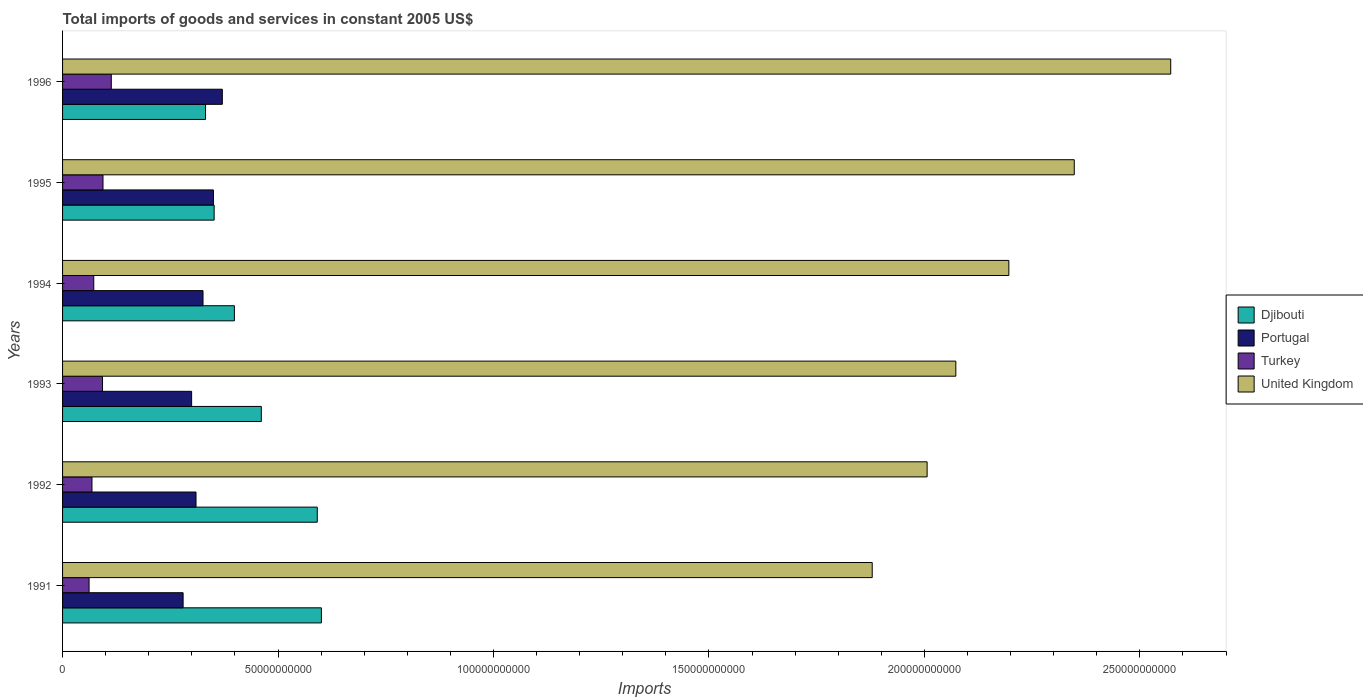How many bars are there on the 3rd tick from the top?
Offer a very short reply. 4. What is the label of the 4th group of bars from the top?
Offer a very short reply. 1993. What is the total imports of goods and services in Turkey in 1996?
Provide a succinct answer. 1.13e+1. Across all years, what is the maximum total imports of goods and services in Djibouti?
Ensure brevity in your answer.  6.01e+1. Across all years, what is the minimum total imports of goods and services in Djibouti?
Make the answer very short. 3.32e+1. What is the total total imports of goods and services in Turkey in the graph?
Give a very brief answer. 5.02e+1. What is the difference between the total imports of goods and services in Djibouti in 1991 and that in 1993?
Your answer should be very brief. 1.39e+1. What is the difference between the total imports of goods and services in United Kingdom in 1994 and the total imports of goods and services in Turkey in 1993?
Provide a succinct answer. 2.10e+11. What is the average total imports of goods and services in Turkey per year?
Make the answer very short. 8.36e+09. In the year 1993, what is the difference between the total imports of goods and services in Turkey and total imports of goods and services in Djibouti?
Offer a very short reply. -3.69e+1. What is the ratio of the total imports of goods and services in Djibouti in 1994 to that in 1996?
Ensure brevity in your answer.  1.2. Is the total imports of goods and services in Turkey in 1992 less than that in 1994?
Offer a very short reply. Yes. Is the difference between the total imports of goods and services in Turkey in 1991 and 1994 greater than the difference between the total imports of goods and services in Djibouti in 1991 and 1994?
Provide a short and direct response. No. What is the difference between the highest and the second highest total imports of goods and services in Portugal?
Give a very brief answer. 2.06e+09. What is the difference between the highest and the lowest total imports of goods and services in Djibouti?
Your answer should be very brief. 2.69e+1. Is the sum of the total imports of goods and services in Turkey in 1993 and 1994 greater than the maximum total imports of goods and services in Djibouti across all years?
Your answer should be very brief. No. Is it the case that in every year, the sum of the total imports of goods and services in Turkey and total imports of goods and services in Portugal is greater than the sum of total imports of goods and services in United Kingdom and total imports of goods and services in Djibouti?
Provide a succinct answer. No. Is it the case that in every year, the sum of the total imports of goods and services in Portugal and total imports of goods and services in United Kingdom is greater than the total imports of goods and services in Djibouti?
Provide a short and direct response. Yes. How many bars are there?
Your answer should be compact. 24. Are all the bars in the graph horizontal?
Provide a short and direct response. Yes. How many years are there in the graph?
Offer a very short reply. 6. Does the graph contain any zero values?
Your response must be concise. No. How are the legend labels stacked?
Your response must be concise. Vertical. What is the title of the graph?
Provide a short and direct response. Total imports of goods and services in constant 2005 US$. Does "Jamaica" appear as one of the legend labels in the graph?
Offer a terse response. No. What is the label or title of the X-axis?
Provide a succinct answer. Imports. What is the label or title of the Y-axis?
Offer a very short reply. Years. What is the Imports in Djibouti in 1991?
Keep it short and to the point. 6.01e+1. What is the Imports of Portugal in 1991?
Give a very brief answer. 2.80e+1. What is the Imports of Turkey in 1991?
Offer a very short reply. 6.15e+09. What is the Imports in United Kingdom in 1991?
Give a very brief answer. 1.88e+11. What is the Imports in Djibouti in 1992?
Offer a very short reply. 5.91e+1. What is the Imports of Portugal in 1992?
Provide a succinct answer. 3.10e+1. What is the Imports in Turkey in 1992?
Keep it short and to the point. 6.82e+09. What is the Imports of United Kingdom in 1992?
Your response must be concise. 2.01e+11. What is the Imports of Djibouti in 1993?
Your answer should be compact. 4.61e+1. What is the Imports of Portugal in 1993?
Offer a very short reply. 2.99e+1. What is the Imports in Turkey in 1993?
Offer a very short reply. 9.27e+09. What is the Imports of United Kingdom in 1993?
Make the answer very short. 2.07e+11. What is the Imports of Djibouti in 1994?
Offer a terse response. 3.99e+1. What is the Imports in Portugal in 1994?
Make the answer very short. 3.26e+1. What is the Imports of Turkey in 1994?
Ensure brevity in your answer.  7.24e+09. What is the Imports of United Kingdom in 1994?
Provide a succinct answer. 2.20e+11. What is the Imports in Djibouti in 1995?
Your response must be concise. 3.52e+1. What is the Imports in Portugal in 1995?
Make the answer very short. 3.50e+1. What is the Imports in Turkey in 1995?
Your answer should be compact. 9.38e+09. What is the Imports in United Kingdom in 1995?
Your answer should be compact. 2.35e+11. What is the Imports in Djibouti in 1996?
Your answer should be compact. 3.32e+1. What is the Imports in Portugal in 1996?
Provide a short and direct response. 3.71e+1. What is the Imports in Turkey in 1996?
Keep it short and to the point. 1.13e+1. What is the Imports of United Kingdom in 1996?
Offer a terse response. 2.57e+11. Across all years, what is the maximum Imports of Djibouti?
Make the answer very short. 6.01e+1. Across all years, what is the maximum Imports in Portugal?
Your response must be concise. 3.71e+1. Across all years, what is the maximum Imports in Turkey?
Give a very brief answer. 1.13e+1. Across all years, what is the maximum Imports of United Kingdom?
Offer a terse response. 2.57e+11. Across all years, what is the minimum Imports in Djibouti?
Make the answer very short. 3.32e+1. Across all years, what is the minimum Imports in Portugal?
Keep it short and to the point. 2.80e+1. Across all years, what is the minimum Imports of Turkey?
Offer a very short reply. 6.15e+09. Across all years, what is the minimum Imports of United Kingdom?
Your response must be concise. 1.88e+11. What is the total Imports in Djibouti in the graph?
Make the answer very short. 2.74e+11. What is the total Imports of Portugal in the graph?
Offer a very short reply. 1.94e+11. What is the total Imports of Turkey in the graph?
Ensure brevity in your answer.  5.02e+1. What is the total Imports of United Kingdom in the graph?
Ensure brevity in your answer.  1.31e+12. What is the difference between the Imports in Djibouti in 1991 and that in 1992?
Your answer should be compact. 9.62e+08. What is the difference between the Imports in Portugal in 1991 and that in 1992?
Provide a succinct answer. -2.99e+09. What is the difference between the Imports in Turkey in 1991 and that in 1992?
Keep it short and to the point. -6.72e+08. What is the difference between the Imports in United Kingdom in 1991 and that in 1992?
Provide a short and direct response. -1.27e+1. What is the difference between the Imports of Djibouti in 1991 and that in 1993?
Keep it short and to the point. 1.39e+1. What is the difference between the Imports in Portugal in 1991 and that in 1993?
Offer a very short reply. -1.97e+09. What is the difference between the Imports of Turkey in 1991 and that in 1993?
Your answer should be very brief. -3.11e+09. What is the difference between the Imports in United Kingdom in 1991 and that in 1993?
Your response must be concise. -1.94e+1. What is the difference between the Imports in Djibouti in 1991 and that in 1994?
Give a very brief answer. 2.02e+1. What is the difference between the Imports in Portugal in 1991 and that in 1994?
Provide a short and direct response. -4.62e+09. What is the difference between the Imports in Turkey in 1991 and that in 1994?
Offer a very short reply. -1.09e+09. What is the difference between the Imports in United Kingdom in 1991 and that in 1994?
Provide a short and direct response. -3.17e+1. What is the difference between the Imports of Djibouti in 1991 and that in 1995?
Offer a terse response. 2.49e+1. What is the difference between the Imports in Portugal in 1991 and that in 1995?
Provide a short and direct response. -7.04e+09. What is the difference between the Imports of Turkey in 1991 and that in 1995?
Provide a short and direct response. -3.23e+09. What is the difference between the Imports of United Kingdom in 1991 and that in 1995?
Give a very brief answer. -4.69e+1. What is the difference between the Imports of Djibouti in 1991 and that in 1996?
Make the answer very short. 2.69e+1. What is the difference between the Imports of Portugal in 1991 and that in 1996?
Provide a succinct answer. -9.10e+09. What is the difference between the Imports in Turkey in 1991 and that in 1996?
Offer a very short reply. -5.15e+09. What is the difference between the Imports in United Kingdom in 1991 and that in 1996?
Your answer should be compact. -6.93e+1. What is the difference between the Imports in Djibouti in 1992 and that in 1993?
Ensure brevity in your answer.  1.30e+1. What is the difference between the Imports of Portugal in 1992 and that in 1993?
Offer a very short reply. 1.02e+09. What is the difference between the Imports of Turkey in 1992 and that in 1993?
Your answer should be compact. -2.44e+09. What is the difference between the Imports of United Kingdom in 1992 and that in 1993?
Keep it short and to the point. -6.66e+09. What is the difference between the Imports in Djibouti in 1992 and that in 1994?
Offer a very short reply. 1.92e+1. What is the difference between the Imports in Portugal in 1992 and that in 1994?
Give a very brief answer. -1.62e+09. What is the difference between the Imports in Turkey in 1992 and that in 1994?
Make the answer very short. -4.15e+08. What is the difference between the Imports of United Kingdom in 1992 and that in 1994?
Keep it short and to the point. -1.90e+1. What is the difference between the Imports of Djibouti in 1992 and that in 1995?
Make the answer very short. 2.39e+1. What is the difference between the Imports in Portugal in 1992 and that in 1995?
Provide a short and direct response. -4.04e+09. What is the difference between the Imports of Turkey in 1992 and that in 1995?
Offer a very short reply. -2.56e+09. What is the difference between the Imports of United Kingdom in 1992 and that in 1995?
Give a very brief answer. -3.41e+1. What is the difference between the Imports of Djibouti in 1992 and that in 1996?
Your answer should be compact. 2.59e+1. What is the difference between the Imports of Portugal in 1992 and that in 1996?
Offer a very short reply. -6.10e+09. What is the difference between the Imports in Turkey in 1992 and that in 1996?
Your answer should be compact. -4.48e+09. What is the difference between the Imports in United Kingdom in 1992 and that in 1996?
Keep it short and to the point. -5.65e+1. What is the difference between the Imports of Djibouti in 1993 and that in 1994?
Your answer should be very brief. 6.25e+09. What is the difference between the Imports of Portugal in 1993 and that in 1994?
Give a very brief answer. -2.64e+09. What is the difference between the Imports in Turkey in 1993 and that in 1994?
Your answer should be very brief. 2.03e+09. What is the difference between the Imports in United Kingdom in 1993 and that in 1994?
Provide a short and direct response. -1.23e+1. What is the difference between the Imports in Djibouti in 1993 and that in 1995?
Your response must be concise. 1.09e+1. What is the difference between the Imports in Portugal in 1993 and that in 1995?
Provide a succinct answer. -5.06e+09. What is the difference between the Imports in Turkey in 1993 and that in 1995?
Make the answer very short. -1.15e+08. What is the difference between the Imports in United Kingdom in 1993 and that in 1995?
Your answer should be very brief. -2.75e+1. What is the difference between the Imports of Djibouti in 1993 and that in 1996?
Make the answer very short. 1.29e+1. What is the difference between the Imports of Portugal in 1993 and that in 1996?
Your response must be concise. -7.13e+09. What is the difference between the Imports of Turkey in 1993 and that in 1996?
Make the answer very short. -2.04e+09. What is the difference between the Imports of United Kingdom in 1993 and that in 1996?
Make the answer very short. -4.99e+1. What is the difference between the Imports of Djibouti in 1994 and that in 1995?
Give a very brief answer. 4.70e+09. What is the difference between the Imports in Portugal in 1994 and that in 1995?
Offer a very short reply. -2.42e+09. What is the difference between the Imports of Turkey in 1994 and that in 1995?
Your answer should be very brief. -2.14e+09. What is the difference between the Imports of United Kingdom in 1994 and that in 1995?
Provide a short and direct response. -1.52e+1. What is the difference between the Imports of Djibouti in 1994 and that in 1996?
Provide a succinct answer. 6.69e+09. What is the difference between the Imports in Portugal in 1994 and that in 1996?
Your response must be concise. -4.48e+09. What is the difference between the Imports in Turkey in 1994 and that in 1996?
Provide a succinct answer. -4.07e+09. What is the difference between the Imports in United Kingdom in 1994 and that in 1996?
Your answer should be compact. -3.76e+1. What is the difference between the Imports of Djibouti in 1995 and that in 1996?
Offer a terse response. 2.00e+09. What is the difference between the Imports of Portugal in 1995 and that in 1996?
Ensure brevity in your answer.  -2.06e+09. What is the difference between the Imports of Turkey in 1995 and that in 1996?
Make the answer very short. -1.93e+09. What is the difference between the Imports of United Kingdom in 1995 and that in 1996?
Your answer should be very brief. -2.24e+1. What is the difference between the Imports of Djibouti in 1991 and the Imports of Portugal in 1992?
Offer a very short reply. 2.91e+1. What is the difference between the Imports of Djibouti in 1991 and the Imports of Turkey in 1992?
Keep it short and to the point. 5.32e+1. What is the difference between the Imports of Djibouti in 1991 and the Imports of United Kingdom in 1992?
Offer a terse response. -1.41e+11. What is the difference between the Imports of Portugal in 1991 and the Imports of Turkey in 1992?
Ensure brevity in your answer.  2.11e+1. What is the difference between the Imports of Portugal in 1991 and the Imports of United Kingdom in 1992?
Your answer should be very brief. -1.73e+11. What is the difference between the Imports of Turkey in 1991 and the Imports of United Kingdom in 1992?
Your answer should be very brief. -1.94e+11. What is the difference between the Imports of Djibouti in 1991 and the Imports of Portugal in 1993?
Ensure brevity in your answer.  3.01e+1. What is the difference between the Imports in Djibouti in 1991 and the Imports in Turkey in 1993?
Provide a short and direct response. 5.08e+1. What is the difference between the Imports in Djibouti in 1991 and the Imports in United Kingdom in 1993?
Offer a very short reply. -1.47e+11. What is the difference between the Imports of Portugal in 1991 and the Imports of Turkey in 1993?
Your answer should be very brief. 1.87e+1. What is the difference between the Imports in Portugal in 1991 and the Imports in United Kingdom in 1993?
Your response must be concise. -1.79e+11. What is the difference between the Imports in Turkey in 1991 and the Imports in United Kingdom in 1993?
Give a very brief answer. -2.01e+11. What is the difference between the Imports of Djibouti in 1991 and the Imports of Portugal in 1994?
Your answer should be very brief. 2.75e+1. What is the difference between the Imports of Djibouti in 1991 and the Imports of Turkey in 1994?
Your answer should be compact. 5.28e+1. What is the difference between the Imports of Djibouti in 1991 and the Imports of United Kingdom in 1994?
Provide a succinct answer. -1.60e+11. What is the difference between the Imports of Portugal in 1991 and the Imports of Turkey in 1994?
Offer a very short reply. 2.07e+1. What is the difference between the Imports of Portugal in 1991 and the Imports of United Kingdom in 1994?
Make the answer very short. -1.92e+11. What is the difference between the Imports of Turkey in 1991 and the Imports of United Kingdom in 1994?
Your answer should be very brief. -2.13e+11. What is the difference between the Imports in Djibouti in 1991 and the Imports in Portugal in 1995?
Offer a very short reply. 2.51e+1. What is the difference between the Imports of Djibouti in 1991 and the Imports of Turkey in 1995?
Make the answer very short. 5.07e+1. What is the difference between the Imports in Djibouti in 1991 and the Imports in United Kingdom in 1995?
Offer a very short reply. -1.75e+11. What is the difference between the Imports in Portugal in 1991 and the Imports in Turkey in 1995?
Provide a succinct answer. 1.86e+1. What is the difference between the Imports in Portugal in 1991 and the Imports in United Kingdom in 1995?
Ensure brevity in your answer.  -2.07e+11. What is the difference between the Imports of Turkey in 1991 and the Imports of United Kingdom in 1995?
Keep it short and to the point. -2.29e+11. What is the difference between the Imports in Djibouti in 1991 and the Imports in Portugal in 1996?
Provide a succinct answer. 2.30e+1. What is the difference between the Imports of Djibouti in 1991 and the Imports of Turkey in 1996?
Offer a very short reply. 4.88e+1. What is the difference between the Imports in Djibouti in 1991 and the Imports in United Kingdom in 1996?
Your answer should be very brief. -1.97e+11. What is the difference between the Imports in Portugal in 1991 and the Imports in Turkey in 1996?
Provide a succinct answer. 1.67e+1. What is the difference between the Imports of Portugal in 1991 and the Imports of United Kingdom in 1996?
Offer a terse response. -2.29e+11. What is the difference between the Imports of Turkey in 1991 and the Imports of United Kingdom in 1996?
Your response must be concise. -2.51e+11. What is the difference between the Imports of Djibouti in 1992 and the Imports of Portugal in 1993?
Provide a succinct answer. 2.92e+1. What is the difference between the Imports of Djibouti in 1992 and the Imports of Turkey in 1993?
Offer a very short reply. 4.98e+1. What is the difference between the Imports in Djibouti in 1992 and the Imports in United Kingdom in 1993?
Your answer should be very brief. -1.48e+11. What is the difference between the Imports of Portugal in 1992 and the Imports of Turkey in 1993?
Your response must be concise. 2.17e+1. What is the difference between the Imports of Portugal in 1992 and the Imports of United Kingdom in 1993?
Provide a succinct answer. -1.76e+11. What is the difference between the Imports of Turkey in 1992 and the Imports of United Kingdom in 1993?
Provide a short and direct response. -2.00e+11. What is the difference between the Imports in Djibouti in 1992 and the Imports in Portugal in 1994?
Your response must be concise. 2.65e+1. What is the difference between the Imports of Djibouti in 1992 and the Imports of Turkey in 1994?
Offer a terse response. 5.19e+1. What is the difference between the Imports of Djibouti in 1992 and the Imports of United Kingdom in 1994?
Make the answer very short. -1.60e+11. What is the difference between the Imports in Portugal in 1992 and the Imports in Turkey in 1994?
Provide a short and direct response. 2.37e+1. What is the difference between the Imports of Portugal in 1992 and the Imports of United Kingdom in 1994?
Your answer should be compact. -1.89e+11. What is the difference between the Imports in Turkey in 1992 and the Imports in United Kingdom in 1994?
Offer a terse response. -2.13e+11. What is the difference between the Imports of Djibouti in 1992 and the Imports of Portugal in 1995?
Your response must be concise. 2.41e+1. What is the difference between the Imports of Djibouti in 1992 and the Imports of Turkey in 1995?
Your answer should be compact. 4.97e+1. What is the difference between the Imports in Djibouti in 1992 and the Imports in United Kingdom in 1995?
Provide a succinct answer. -1.76e+11. What is the difference between the Imports in Portugal in 1992 and the Imports in Turkey in 1995?
Provide a short and direct response. 2.16e+1. What is the difference between the Imports in Portugal in 1992 and the Imports in United Kingdom in 1995?
Your answer should be compact. -2.04e+11. What is the difference between the Imports of Turkey in 1992 and the Imports of United Kingdom in 1995?
Offer a terse response. -2.28e+11. What is the difference between the Imports in Djibouti in 1992 and the Imports in Portugal in 1996?
Give a very brief answer. 2.20e+1. What is the difference between the Imports of Djibouti in 1992 and the Imports of Turkey in 1996?
Provide a succinct answer. 4.78e+1. What is the difference between the Imports in Djibouti in 1992 and the Imports in United Kingdom in 1996?
Ensure brevity in your answer.  -1.98e+11. What is the difference between the Imports of Portugal in 1992 and the Imports of Turkey in 1996?
Your answer should be very brief. 1.97e+1. What is the difference between the Imports of Portugal in 1992 and the Imports of United Kingdom in 1996?
Provide a succinct answer. -2.26e+11. What is the difference between the Imports in Turkey in 1992 and the Imports in United Kingdom in 1996?
Offer a terse response. -2.50e+11. What is the difference between the Imports in Djibouti in 1993 and the Imports in Portugal in 1994?
Your answer should be very brief. 1.35e+1. What is the difference between the Imports in Djibouti in 1993 and the Imports in Turkey in 1994?
Make the answer very short. 3.89e+1. What is the difference between the Imports of Djibouti in 1993 and the Imports of United Kingdom in 1994?
Your answer should be compact. -1.73e+11. What is the difference between the Imports in Portugal in 1993 and the Imports in Turkey in 1994?
Make the answer very short. 2.27e+1. What is the difference between the Imports of Portugal in 1993 and the Imports of United Kingdom in 1994?
Ensure brevity in your answer.  -1.90e+11. What is the difference between the Imports in Turkey in 1993 and the Imports in United Kingdom in 1994?
Make the answer very short. -2.10e+11. What is the difference between the Imports of Djibouti in 1993 and the Imports of Portugal in 1995?
Ensure brevity in your answer.  1.11e+1. What is the difference between the Imports of Djibouti in 1993 and the Imports of Turkey in 1995?
Provide a succinct answer. 3.67e+1. What is the difference between the Imports of Djibouti in 1993 and the Imports of United Kingdom in 1995?
Provide a succinct answer. -1.89e+11. What is the difference between the Imports of Portugal in 1993 and the Imports of Turkey in 1995?
Ensure brevity in your answer.  2.06e+1. What is the difference between the Imports in Portugal in 1993 and the Imports in United Kingdom in 1995?
Give a very brief answer. -2.05e+11. What is the difference between the Imports of Turkey in 1993 and the Imports of United Kingdom in 1995?
Keep it short and to the point. -2.26e+11. What is the difference between the Imports of Djibouti in 1993 and the Imports of Portugal in 1996?
Keep it short and to the point. 9.05e+09. What is the difference between the Imports of Djibouti in 1993 and the Imports of Turkey in 1996?
Provide a succinct answer. 3.48e+1. What is the difference between the Imports in Djibouti in 1993 and the Imports in United Kingdom in 1996?
Your response must be concise. -2.11e+11. What is the difference between the Imports of Portugal in 1993 and the Imports of Turkey in 1996?
Keep it short and to the point. 1.86e+1. What is the difference between the Imports in Portugal in 1993 and the Imports in United Kingdom in 1996?
Make the answer very short. -2.27e+11. What is the difference between the Imports of Turkey in 1993 and the Imports of United Kingdom in 1996?
Offer a very short reply. -2.48e+11. What is the difference between the Imports of Djibouti in 1994 and the Imports of Portugal in 1995?
Your response must be concise. 4.86e+09. What is the difference between the Imports in Djibouti in 1994 and the Imports in Turkey in 1995?
Offer a terse response. 3.05e+1. What is the difference between the Imports in Djibouti in 1994 and the Imports in United Kingdom in 1995?
Your answer should be very brief. -1.95e+11. What is the difference between the Imports in Portugal in 1994 and the Imports in Turkey in 1995?
Your answer should be compact. 2.32e+1. What is the difference between the Imports in Portugal in 1994 and the Imports in United Kingdom in 1995?
Your answer should be very brief. -2.02e+11. What is the difference between the Imports of Turkey in 1994 and the Imports of United Kingdom in 1995?
Offer a very short reply. -2.28e+11. What is the difference between the Imports in Djibouti in 1994 and the Imports in Portugal in 1996?
Your answer should be very brief. 2.80e+09. What is the difference between the Imports of Djibouti in 1994 and the Imports of Turkey in 1996?
Offer a very short reply. 2.86e+1. What is the difference between the Imports in Djibouti in 1994 and the Imports in United Kingdom in 1996?
Give a very brief answer. -2.17e+11. What is the difference between the Imports in Portugal in 1994 and the Imports in Turkey in 1996?
Your answer should be compact. 2.13e+1. What is the difference between the Imports of Portugal in 1994 and the Imports of United Kingdom in 1996?
Keep it short and to the point. -2.25e+11. What is the difference between the Imports of Turkey in 1994 and the Imports of United Kingdom in 1996?
Provide a succinct answer. -2.50e+11. What is the difference between the Imports in Djibouti in 1995 and the Imports in Portugal in 1996?
Offer a very short reply. -1.90e+09. What is the difference between the Imports of Djibouti in 1995 and the Imports of Turkey in 1996?
Keep it short and to the point. 2.39e+1. What is the difference between the Imports of Djibouti in 1995 and the Imports of United Kingdom in 1996?
Offer a very short reply. -2.22e+11. What is the difference between the Imports in Portugal in 1995 and the Imports in Turkey in 1996?
Ensure brevity in your answer.  2.37e+1. What is the difference between the Imports in Portugal in 1995 and the Imports in United Kingdom in 1996?
Offer a very short reply. -2.22e+11. What is the difference between the Imports of Turkey in 1995 and the Imports of United Kingdom in 1996?
Offer a terse response. -2.48e+11. What is the average Imports of Djibouti per year?
Provide a short and direct response. 4.56e+1. What is the average Imports of Portugal per year?
Provide a succinct answer. 3.23e+1. What is the average Imports in Turkey per year?
Your response must be concise. 8.36e+09. What is the average Imports of United Kingdom per year?
Keep it short and to the point. 2.18e+11. In the year 1991, what is the difference between the Imports in Djibouti and Imports in Portugal?
Your answer should be compact. 3.21e+1. In the year 1991, what is the difference between the Imports of Djibouti and Imports of Turkey?
Your answer should be compact. 5.39e+1. In the year 1991, what is the difference between the Imports of Djibouti and Imports of United Kingdom?
Your answer should be very brief. -1.28e+11. In the year 1991, what is the difference between the Imports of Portugal and Imports of Turkey?
Provide a short and direct response. 2.18e+1. In the year 1991, what is the difference between the Imports of Portugal and Imports of United Kingdom?
Give a very brief answer. -1.60e+11. In the year 1991, what is the difference between the Imports of Turkey and Imports of United Kingdom?
Make the answer very short. -1.82e+11. In the year 1992, what is the difference between the Imports in Djibouti and Imports in Portugal?
Your answer should be very brief. 2.81e+1. In the year 1992, what is the difference between the Imports in Djibouti and Imports in Turkey?
Your answer should be compact. 5.23e+1. In the year 1992, what is the difference between the Imports in Djibouti and Imports in United Kingdom?
Your response must be concise. -1.42e+11. In the year 1992, what is the difference between the Imports of Portugal and Imports of Turkey?
Ensure brevity in your answer.  2.41e+1. In the year 1992, what is the difference between the Imports in Portugal and Imports in United Kingdom?
Provide a short and direct response. -1.70e+11. In the year 1992, what is the difference between the Imports of Turkey and Imports of United Kingdom?
Make the answer very short. -1.94e+11. In the year 1993, what is the difference between the Imports of Djibouti and Imports of Portugal?
Offer a very short reply. 1.62e+1. In the year 1993, what is the difference between the Imports in Djibouti and Imports in Turkey?
Make the answer very short. 3.69e+1. In the year 1993, what is the difference between the Imports of Djibouti and Imports of United Kingdom?
Your answer should be very brief. -1.61e+11. In the year 1993, what is the difference between the Imports of Portugal and Imports of Turkey?
Provide a short and direct response. 2.07e+1. In the year 1993, what is the difference between the Imports in Portugal and Imports in United Kingdom?
Give a very brief answer. -1.77e+11. In the year 1993, what is the difference between the Imports in Turkey and Imports in United Kingdom?
Provide a succinct answer. -1.98e+11. In the year 1994, what is the difference between the Imports in Djibouti and Imports in Portugal?
Give a very brief answer. 7.28e+09. In the year 1994, what is the difference between the Imports of Djibouti and Imports of Turkey?
Offer a very short reply. 3.26e+1. In the year 1994, what is the difference between the Imports in Djibouti and Imports in United Kingdom?
Keep it short and to the point. -1.80e+11. In the year 1994, what is the difference between the Imports of Portugal and Imports of Turkey?
Offer a terse response. 2.54e+1. In the year 1994, what is the difference between the Imports in Portugal and Imports in United Kingdom?
Keep it short and to the point. -1.87e+11. In the year 1994, what is the difference between the Imports of Turkey and Imports of United Kingdom?
Your response must be concise. -2.12e+11. In the year 1995, what is the difference between the Imports of Djibouti and Imports of Portugal?
Offer a terse response. 1.65e+08. In the year 1995, what is the difference between the Imports of Djibouti and Imports of Turkey?
Your answer should be compact. 2.58e+1. In the year 1995, what is the difference between the Imports of Djibouti and Imports of United Kingdom?
Provide a short and direct response. -2.00e+11. In the year 1995, what is the difference between the Imports in Portugal and Imports in Turkey?
Offer a very short reply. 2.56e+1. In the year 1995, what is the difference between the Imports in Portugal and Imports in United Kingdom?
Ensure brevity in your answer.  -2.00e+11. In the year 1995, what is the difference between the Imports of Turkey and Imports of United Kingdom?
Offer a terse response. -2.25e+11. In the year 1996, what is the difference between the Imports of Djibouti and Imports of Portugal?
Ensure brevity in your answer.  -3.90e+09. In the year 1996, what is the difference between the Imports in Djibouti and Imports in Turkey?
Your response must be concise. 2.19e+1. In the year 1996, what is the difference between the Imports of Djibouti and Imports of United Kingdom?
Make the answer very short. -2.24e+11. In the year 1996, what is the difference between the Imports of Portugal and Imports of Turkey?
Keep it short and to the point. 2.58e+1. In the year 1996, what is the difference between the Imports in Portugal and Imports in United Kingdom?
Offer a terse response. -2.20e+11. In the year 1996, what is the difference between the Imports of Turkey and Imports of United Kingdom?
Your response must be concise. -2.46e+11. What is the ratio of the Imports of Djibouti in 1991 to that in 1992?
Keep it short and to the point. 1.02. What is the ratio of the Imports in Portugal in 1991 to that in 1992?
Offer a very short reply. 0.9. What is the ratio of the Imports of Turkey in 1991 to that in 1992?
Provide a succinct answer. 0.9. What is the ratio of the Imports of United Kingdom in 1991 to that in 1992?
Your answer should be compact. 0.94. What is the ratio of the Imports of Djibouti in 1991 to that in 1993?
Make the answer very short. 1.3. What is the ratio of the Imports in Portugal in 1991 to that in 1993?
Give a very brief answer. 0.93. What is the ratio of the Imports of Turkey in 1991 to that in 1993?
Your answer should be very brief. 0.66. What is the ratio of the Imports of United Kingdom in 1991 to that in 1993?
Your answer should be very brief. 0.91. What is the ratio of the Imports of Djibouti in 1991 to that in 1994?
Make the answer very short. 1.51. What is the ratio of the Imports of Portugal in 1991 to that in 1994?
Provide a short and direct response. 0.86. What is the ratio of the Imports of Turkey in 1991 to that in 1994?
Your response must be concise. 0.85. What is the ratio of the Imports in United Kingdom in 1991 to that in 1994?
Ensure brevity in your answer.  0.86. What is the ratio of the Imports in Djibouti in 1991 to that in 1995?
Ensure brevity in your answer.  1.71. What is the ratio of the Imports of Portugal in 1991 to that in 1995?
Keep it short and to the point. 0.8. What is the ratio of the Imports in Turkey in 1991 to that in 1995?
Your response must be concise. 0.66. What is the ratio of the Imports in United Kingdom in 1991 to that in 1995?
Offer a terse response. 0.8. What is the ratio of the Imports of Djibouti in 1991 to that in 1996?
Provide a succinct answer. 1.81. What is the ratio of the Imports in Portugal in 1991 to that in 1996?
Your answer should be compact. 0.75. What is the ratio of the Imports in Turkey in 1991 to that in 1996?
Your response must be concise. 0.54. What is the ratio of the Imports in United Kingdom in 1991 to that in 1996?
Keep it short and to the point. 0.73. What is the ratio of the Imports in Djibouti in 1992 to that in 1993?
Ensure brevity in your answer.  1.28. What is the ratio of the Imports in Portugal in 1992 to that in 1993?
Provide a short and direct response. 1.03. What is the ratio of the Imports of Turkey in 1992 to that in 1993?
Offer a terse response. 0.74. What is the ratio of the Imports in United Kingdom in 1992 to that in 1993?
Provide a short and direct response. 0.97. What is the ratio of the Imports in Djibouti in 1992 to that in 1994?
Keep it short and to the point. 1.48. What is the ratio of the Imports of Portugal in 1992 to that in 1994?
Offer a terse response. 0.95. What is the ratio of the Imports in Turkey in 1992 to that in 1994?
Your answer should be very brief. 0.94. What is the ratio of the Imports in United Kingdom in 1992 to that in 1994?
Offer a terse response. 0.91. What is the ratio of the Imports of Djibouti in 1992 to that in 1995?
Provide a short and direct response. 1.68. What is the ratio of the Imports in Portugal in 1992 to that in 1995?
Give a very brief answer. 0.88. What is the ratio of the Imports of Turkey in 1992 to that in 1995?
Ensure brevity in your answer.  0.73. What is the ratio of the Imports of United Kingdom in 1992 to that in 1995?
Offer a very short reply. 0.85. What is the ratio of the Imports of Djibouti in 1992 to that in 1996?
Your answer should be compact. 1.78. What is the ratio of the Imports in Portugal in 1992 to that in 1996?
Offer a terse response. 0.84. What is the ratio of the Imports of Turkey in 1992 to that in 1996?
Keep it short and to the point. 0.6. What is the ratio of the Imports in United Kingdom in 1992 to that in 1996?
Give a very brief answer. 0.78. What is the ratio of the Imports in Djibouti in 1993 to that in 1994?
Provide a short and direct response. 1.16. What is the ratio of the Imports in Portugal in 1993 to that in 1994?
Make the answer very short. 0.92. What is the ratio of the Imports in Turkey in 1993 to that in 1994?
Your answer should be compact. 1.28. What is the ratio of the Imports in United Kingdom in 1993 to that in 1994?
Provide a short and direct response. 0.94. What is the ratio of the Imports of Djibouti in 1993 to that in 1995?
Make the answer very short. 1.31. What is the ratio of the Imports in Portugal in 1993 to that in 1995?
Your answer should be compact. 0.86. What is the ratio of the Imports in United Kingdom in 1993 to that in 1995?
Your answer should be very brief. 0.88. What is the ratio of the Imports of Djibouti in 1993 to that in 1996?
Offer a terse response. 1.39. What is the ratio of the Imports in Portugal in 1993 to that in 1996?
Provide a short and direct response. 0.81. What is the ratio of the Imports of Turkey in 1993 to that in 1996?
Provide a succinct answer. 0.82. What is the ratio of the Imports of United Kingdom in 1993 to that in 1996?
Your answer should be compact. 0.81. What is the ratio of the Imports of Djibouti in 1994 to that in 1995?
Give a very brief answer. 1.13. What is the ratio of the Imports of Portugal in 1994 to that in 1995?
Your answer should be compact. 0.93. What is the ratio of the Imports of Turkey in 1994 to that in 1995?
Make the answer very short. 0.77. What is the ratio of the Imports of United Kingdom in 1994 to that in 1995?
Give a very brief answer. 0.94. What is the ratio of the Imports in Djibouti in 1994 to that in 1996?
Your response must be concise. 1.2. What is the ratio of the Imports in Portugal in 1994 to that in 1996?
Provide a succinct answer. 0.88. What is the ratio of the Imports in Turkey in 1994 to that in 1996?
Provide a short and direct response. 0.64. What is the ratio of the Imports of United Kingdom in 1994 to that in 1996?
Provide a succinct answer. 0.85. What is the ratio of the Imports in Djibouti in 1995 to that in 1996?
Your response must be concise. 1.06. What is the ratio of the Imports in Portugal in 1995 to that in 1996?
Offer a very short reply. 0.94. What is the ratio of the Imports of Turkey in 1995 to that in 1996?
Ensure brevity in your answer.  0.83. What is the ratio of the Imports of United Kingdom in 1995 to that in 1996?
Offer a terse response. 0.91. What is the difference between the highest and the second highest Imports in Djibouti?
Ensure brevity in your answer.  9.62e+08. What is the difference between the highest and the second highest Imports of Portugal?
Make the answer very short. 2.06e+09. What is the difference between the highest and the second highest Imports in Turkey?
Provide a short and direct response. 1.93e+09. What is the difference between the highest and the second highest Imports in United Kingdom?
Your answer should be compact. 2.24e+1. What is the difference between the highest and the lowest Imports of Djibouti?
Offer a terse response. 2.69e+1. What is the difference between the highest and the lowest Imports in Portugal?
Offer a terse response. 9.10e+09. What is the difference between the highest and the lowest Imports in Turkey?
Your answer should be very brief. 5.15e+09. What is the difference between the highest and the lowest Imports in United Kingdom?
Give a very brief answer. 6.93e+1. 